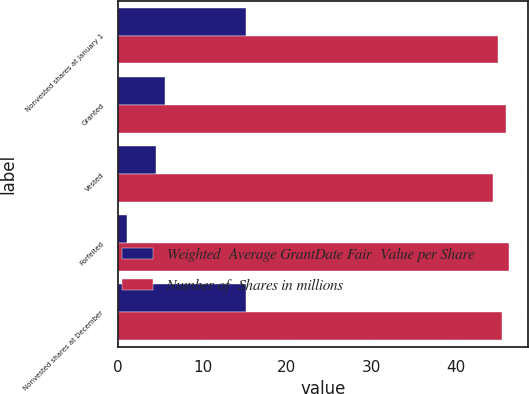Convert chart to OTSL. <chart><loc_0><loc_0><loc_500><loc_500><stacked_bar_chart><ecel><fcel>Nonvested shares at January 1<fcel>Granted<fcel>Vested<fcel>Forfeited<fcel>Nonvested shares at December<nl><fcel>Weighted  Average GrantDate Fair  Value per Share<fcel>15.1<fcel>5.6<fcel>4.5<fcel>1.1<fcel>15.1<nl><fcel>Number of  Shares in millions<fcel>44.96<fcel>45.99<fcel>44.4<fcel>46.25<fcel>45.42<nl></chart> 